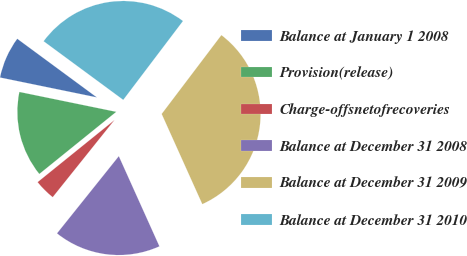<chart> <loc_0><loc_0><loc_500><loc_500><pie_chart><fcel>Balance at January 1 2008<fcel>Provision(release)<fcel>Charge-offsnetofrecoveries<fcel>Balance at December 31 2008<fcel>Balance at December 31 2009<fcel>Balance at December 31 2010<nl><fcel>6.88%<fcel>14.04%<fcel>3.44%<fcel>17.48%<fcel>32.95%<fcel>25.21%<nl></chart> 